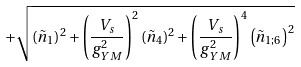Convert formula to latex. <formula><loc_0><loc_0><loc_500><loc_500>\, + \sqrt { \left ( \tilde { n } _ { 1 } \right ) ^ { 2 } + \left ( \frac { V _ { s } } { g _ { Y M } ^ { 2 } } \right ) ^ { 2 } \left ( \tilde { n } _ { 4 } \right ) ^ { 2 } + \left ( \frac { V _ { s } } { g _ { Y M } ^ { 2 } } \right ) ^ { 4 } \left ( \tilde { n } _ { 1 ; 6 } \right ) ^ { 2 } }</formula> 